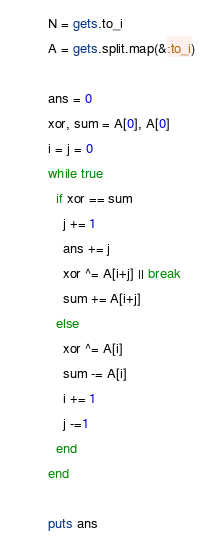Convert code to text. <code><loc_0><loc_0><loc_500><loc_500><_Ruby_>N = gets.to_i
A = gets.split.map(&:to_i)

ans = 0
xor, sum = A[0], A[0]
i = j = 0
while true
  if xor == sum
    j += 1
    ans += j
    xor ^= A[i+j] || break
    sum += A[i+j]
  else
    xor ^= A[i]
    sum -= A[i]
    i += 1
    j -=1
  end
end

puts ans
</code> 